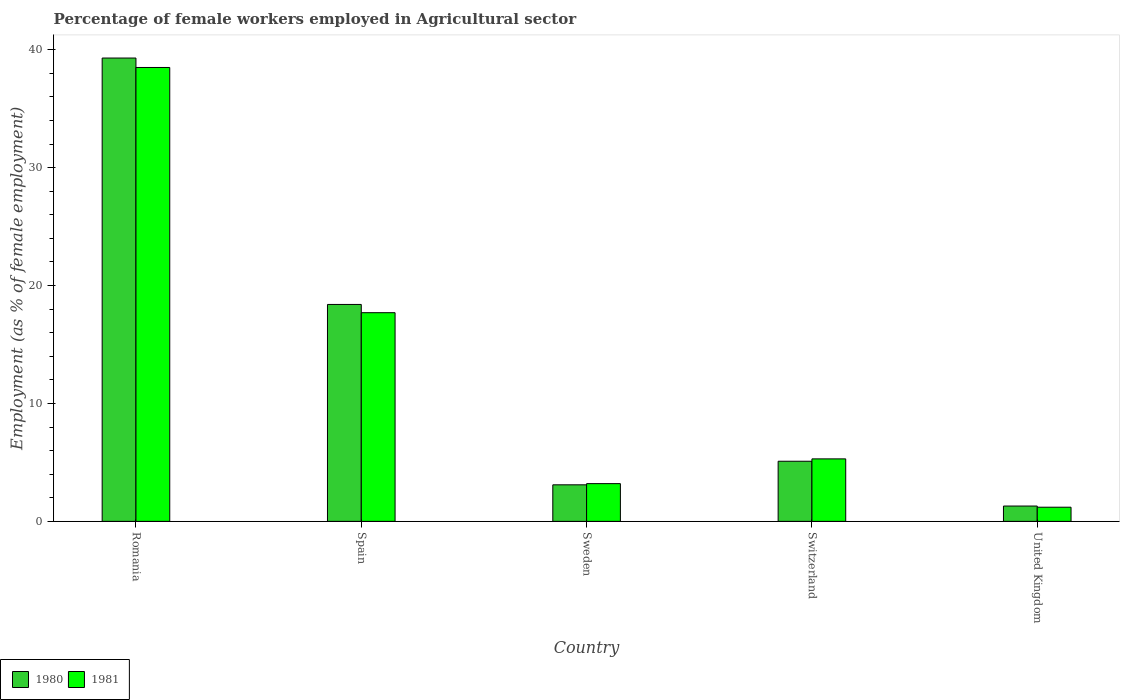Are the number of bars per tick equal to the number of legend labels?
Keep it short and to the point. Yes. What is the label of the 5th group of bars from the left?
Offer a very short reply. United Kingdom. What is the percentage of females employed in Agricultural sector in 1981 in Spain?
Your response must be concise. 17.7. Across all countries, what is the maximum percentage of females employed in Agricultural sector in 1981?
Your response must be concise. 38.5. Across all countries, what is the minimum percentage of females employed in Agricultural sector in 1981?
Offer a terse response. 1.2. In which country was the percentage of females employed in Agricultural sector in 1980 maximum?
Your answer should be very brief. Romania. What is the total percentage of females employed in Agricultural sector in 1980 in the graph?
Provide a succinct answer. 67.2. What is the difference between the percentage of females employed in Agricultural sector in 1980 in Switzerland and the percentage of females employed in Agricultural sector in 1981 in United Kingdom?
Your answer should be very brief. 3.9. What is the average percentage of females employed in Agricultural sector in 1981 per country?
Ensure brevity in your answer.  13.18. What is the difference between the percentage of females employed in Agricultural sector of/in 1980 and percentage of females employed in Agricultural sector of/in 1981 in Spain?
Keep it short and to the point. 0.7. In how many countries, is the percentage of females employed in Agricultural sector in 1980 greater than 24 %?
Your response must be concise. 1. What is the ratio of the percentage of females employed in Agricultural sector in 1981 in Sweden to that in Switzerland?
Offer a terse response. 0.6. Is the percentage of females employed in Agricultural sector in 1980 in Romania less than that in United Kingdom?
Your response must be concise. No. What is the difference between the highest and the second highest percentage of females employed in Agricultural sector in 1980?
Make the answer very short. 13.3. What is the difference between the highest and the lowest percentage of females employed in Agricultural sector in 1980?
Offer a terse response. 38. In how many countries, is the percentage of females employed in Agricultural sector in 1980 greater than the average percentage of females employed in Agricultural sector in 1980 taken over all countries?
Provide a succinct answer. 2. Is the sum of the percentage of females employed in Agricultural sector in 1980 in Spain and Switzerland greater than the maximum percentage of females employed in Agricultural sector in 1981 across all countries?
Your response must be concise. No. What does the 2nd bar from the left in Romania represents?
Ensure brevity in your answer.  1981. How many bars are there?
Offer a very short reply. 10. How many countries are there in the graph?
Offer a very short reply. 5. Are the values on the major ticks of Y-axis written in scientific E-notation?
Keep it short and to the point. No. Does the graph contain any zero values?
Give a very brief answer. No. Does the graph contain grids?
Offer a very short reply. No. How many legend labels are there?
Your response must be concise. 2. What is the title of the graph?
Your answer should be compact. Percentage of female workers employed in Agricultural sector. What is the label or title of the Y-axis?
Your answer should be compact. Employment (as % of female employment). What is the Employment (as % of female employment) in 1980 in Romania?
Offer a very short reply. 39.3. What is the Employment (as % of female employment) in 1981 in Romania?
Your answer should be compact. 38.5. What is the Employment (as % of female employment) in 1980 in Spain?
Your answer should be very brief. 18.4. What is the Employment (as % of female employment) of 1981 in Spain?
Keep it short and to the point. 17.7. What is the Employment (as % of female employment) of 1980 in Sweden?
Make the answer very short. 3.1. What is the Employment (as % of female employment) in 1981 in Sweden?
Keep it short and to the point. 3.2. What is the Employment (as % of female employment) in 1980 in Switzerland?
Give a very brief answer. 5.1. What is the Employment (as % of female employment) of 1981 in Switzerland?
Make the answer very short. 5.3. What is the Employment (as % of female employment) of 1980 in United Kingdom?
Make the answer very short. 1.3. What is the Employment (as % of female employment) of 1981 in United Kingdom?
Ensure brevity in your answer.  1.2. Across all countries, what is the maximum Employment (as % of female employment) of 1980?
Provide a succinct answer. 39.3. Across all countries, what is the maximum Employment (as % of female employment) in 1981?
Your answer should be compact. 38.5. Across all countries, what is the minimum Employment (as % of female employment) of 1980?
Keep it short and to the point. 1.3. Across all countries, what is the minimum Employment (as % of female employment) of 1981?
Give a very brief answer. 1.2. What is the total Employment (as % of female employment) in 1980 in the graph?
Your answer should be compact. 67.2. What is the total Employment (as % of female employment) of 1981 in the graph?
Give a very brief answer. 65.9. What is the difference between the Employment (as % of female employment) of 1980 in Romania and that in Spain?
Keep it short and to the point. 20.9. What is the difference between the Employment (as % of female employment) in 1981 in Romania and that in Spain?
Offer a terse response. 20.8. What is the difference between the Employment (as % of female employment) of 1980 in Romania and that in Sweden?
Give a very brief answer. 36.2. What is the difference between the Employment (as % of female employment) of 1981 in Romania and that in Sweden?
Give a very brief answer. 35.3. What is the difference between the Employment (as % of female employment) of 1980 in Romania and that in Switzerland?
Your response must be concise. 34.2. What is the difference between the Employment (as % of female employment) of 1981 in Romania and that in Switzerland?
Keep it short and to the point. 33.2. What is the difference between the Employment (as % of female employment) of 1980 in Romania and that in United Kingdom?
Provide a short and direct response. 38. What is the difference between the Employment (as % of female employment) of 1981 in Romania and that in United Kingdom?
Make the answer very short. 37.3. What is the difference between the Employment (as % of female employment) in 1980 in Spain and that in Sweden?
Provide a succinct answer. 15.3. What is the difference between the Employment (as % of female employment) in 1981 in Spain and that in Switzerland?
Keep it short and to the point. 12.4. What is the difference between the Employment (as % of female employment) of 1980 in Spain and that in United Kingdom?
Your response must be concise. 17.1. What is the difference between the Employment (as % of female employment) in 1981 in Sweden and that in Switzerland?
Your response must be concise. -2.1. What is the difference between the Employment (as % of female employment) in 1981 in Sweden and that in United Kingdom?
Provide a succinct answer. 2. What is the difference between the Employment (as % of female employment) in 1980 in Romania and the Employment (as % of female employment) in 1981 in Spain?
Your answer should be compact. 21.6. What is the difference between the Employment (as % of female employment) in 1980 in Romania and the Employment (as % of female employment) in 1981 in Sweden?
Offer a very short reply. 36.1. What is the difference between the Employment (as % of female employment) of 1980 in Romania and the Employment (as % of female employment) of 1981 in United Kingdom?
Make the answer very short. 38.1. What is the difference between the Employment (as % of female employment) of 1980 in Spain and the Employment (as % of female employment) of 1981 in Sweden?
Ensure brevity in your answer.  15.2. What is the difference between the Employment (as % of female employment) in 1980 in Spain and the Employment (as % of female employment) in 1981 in United Kingdom?
Offer a very short reply. 17.2. What is the difference between the Employment (as % of female employment) of 1980 in Sweden and the Employment (as % of female employment) of 1981 in Switzerland?
Provide a succinct answer. -2.2. What is the difference between the Employment (as % of female employment) in 1980 in Sweden and the Employment (as % of female employment) in 1981 in United Kingdom?
Your answer should be very brief. 1.9. What is the average Employment (as % of female employment) in 1980 per country?
Your answer should be compact. 13.44. What is the average Employment (as % of female employment) in 1981 per country?
Provide a succinct answer. 13.18. What is the difference between the Employment (as % of female employment) of 1980 and Employment (as % of female employment) of 1981 in Romania?
Offer a terse response. 0.8. What is the difference between the Employment (as % of female employment) in 1980 and Employment (as % of female employment) in 1981 in Spain?
Keep it short and to the point. 0.7. What is the difference between the Employment (as % of female employment) of 1980 and Employment (as % of female employment) of 1981 in Sweden?
Provide a short and direct response. -0.1. What is the difference between the Employment (as % of female employment) in 1980 and Employment (as % of female employment) in 1981 in Switzerland?
Provide a succinct answer. -0.2. What is the ratio of the Employment (as % of female employment) of 1980 in Romania to that in Spain?
Your answer should be very brief. 2.14. What is the ratio of the Employment (as % of female employment) of 1981 in Romania to that in Spain?
Keep it short and to the point. 2.18. What is the ratio of the Employment (as % of female employment) of 1980 in Romania to that in Sweden?
Offer a terse response. 12.68. What is the ratio of the Employment (as % of female employment) of 1981 in Romania to that in Sweden?
Your answer should be compact. 12.03. What is the ratio of the Employment (as % of female employment) of 1980 in Romania to that in Switzerland?
Your answer should be very brief. 7.71. What is the ratio of the Employment (as % of female employment) in 1981 in Romania to that in Switzerland?
Keep it short and to the point. 7.26. What is the ratio of the Employment (as % of female employment) in 1980 in Romania to that in United Kingdom?
Your answer should be compact. 30.23. What is the ratio of the Employment (as % of female employment) of 1981 in Romania to that in United Kingdom?
Offer a terse response. 32.08. What is the ratio of the Employment (as % of female employment) of 1980 in Spain to that in Sweden?
Your answer should be compact. 5.94. What is the ratio of the Employment (as % of female employment) of 1981 in Spain to that in Sweden?
Give a very brief answer. 5.53. What is the ratio of the Employment (as % of female employment) of 1980 in Spain to that in Switzerland?
Offer a terse response. 3.61. What is the ratio of the Employment (as % of female employment) of 1981 in Spain to that in Switzerland?
Ensure brevity in your answer.  3.34. What is the ratio of the Employment (as % of female employment) of 1980 in Spain to that in United Kingdom?
Ensure brevity in your answer.  14.15. What is the ratio of the Employment (as % of female employment) of 1981 in Spain to that in United Kingdom?
Keep it short and to the point. 14.75. What is the ratio of the Employment (as % of female employment) of 1980 in Sweden to that in Switzerland?
Ensure brevity in your answer.  0.61. What is the ratio of the Employment (as % of female employment) in 1981 in Sweden to that in Switzerland?
Make the answer very short. 0.6. What is the ratio of the Employment (as % of female employment) of 1980 in Sweden to that in United Kingdom?
Provide a succinct answer. 2.38. What is the ratio of the Employment (as % of female employment) of 1981 in Sweden to that in United Kingdom?
Offer a terse response. 2.67. What is the ratio of the Employment (as % of female employment) in 1980 in Switzerland to that in United Kingdom?
Ensure brevity in your answer.  3.92. What is the ratio of the Employment (as % of female employment) in 1981 in Switzerland to that in United Kingdom?
Your answer should be very brief. 4.42. What is the difference between the highest and the second highest Employment (as % of female employment) in 1980?
Offer a very short reply. 20.9. What is the difference between the highest and the second highest Employment (as % of female employment) in 1981?
Your response must be concise. 20.8. What is the difference between the highest and the lowest Employment (as % of female employment) in 1980?
Your answer should be very brief. 38. What is the difference between the highest and the lowest Employment (as % of female employment) of 1981?
Provide a short and direct response. 37.3. 